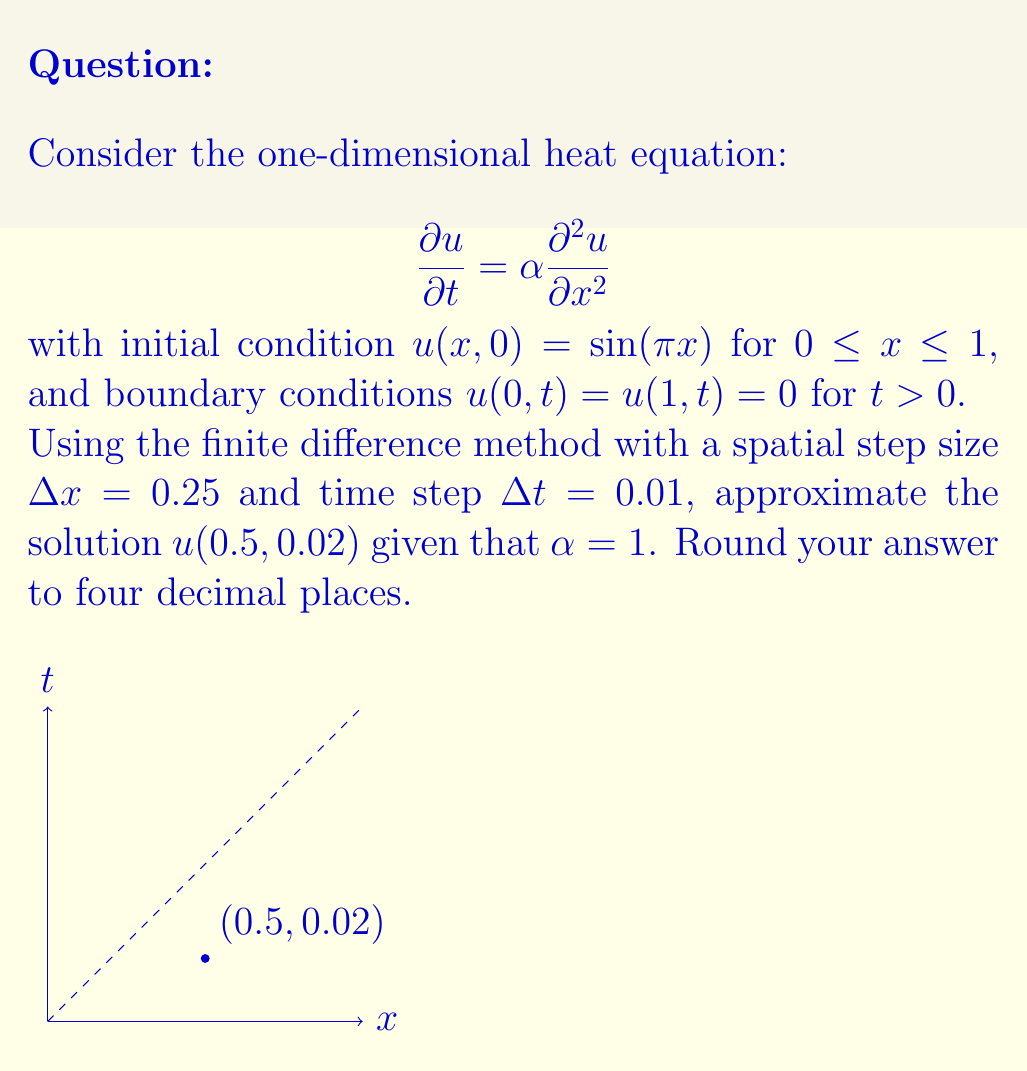Show me your answer to this math problem. Let's solve this step-by-step using the finite difference method:

1) We'll use the forward difference for time and central difference for space:

   $$\frac{u_{i}^{n+1} - u_{i}^n}{\Delta t} = \alpha \frac{u_{i+1}^n - 2u_i^n + u_{i-1}^n}{(\Delta x)^2}$$

2) Rearranging this equation:

   $$u_{i}^{n+1} = u_i^n + \frac{\alpha \Delta t}{(\Delta x)^2}(u_{i+1}^n - 2u_i^n + u_{i-1}^n)$$

3) Let $r = \frac{\alpha \Delta t}{(\Delta x)^2}$. With the given values:

   $$r = \frac{1 \cdot 0.01}{(0.25)^2} = 0.16$$

4) Our equation becomes:

   $$u_{i}^{n+1} = u_i^n + 0.16(u_{i+1}^n - 2u_i^n + u_{i-1}^n)$$

5) We need to calculate two time steps (n = 0 and n = 1) to reach t = 0.02.

6) At t = 0, we use the initial condition:
   
   $$u_i^0 = \sin(\pi x_i)$$

   For x = 0, 0.25, 0.5, 0.75, 1, we get:
   
   $$u_0^0 = 0, u_1^0 \approx 0.7071, u_2^0 = 1, u_3^0 \approx 0.7071, u_4^0 = 0$$

7) For the first time step (n = 0 to n = 1):

   $$u_2^1 = 1 + 0.16(0.7071 - 2 \cdot 1 + 0.7071) = 0.9312$$

8) For the second time step (n = 1 to n = 2):

   $$u_2^2 = 0.9312 + 0.16(u_3^1 - 2 \cdot 0.9312 + u_1^1)$$

   We need to calculate $u_1^1$ and $u_3^1$:

   $$u_1^1 = 0.7071 + 0.16(1 - 2 \cdot 0.7071 + 0) = 0.6599$$
   $$u_3^1 = 0.7071 + 0.16(0 - 2 \cdot 0.7071 + 1) = 0.6599$$

9) Now we can calculate $u_2^2$:

   $$u_2^2 = 0.9312 + 0.16(0.6599 - 2 \cdot 0.9312 + 0.6599) = 0.8687$$

This is our approximation for $u(0.5, 0.02)$.
Answer: 0.8687 